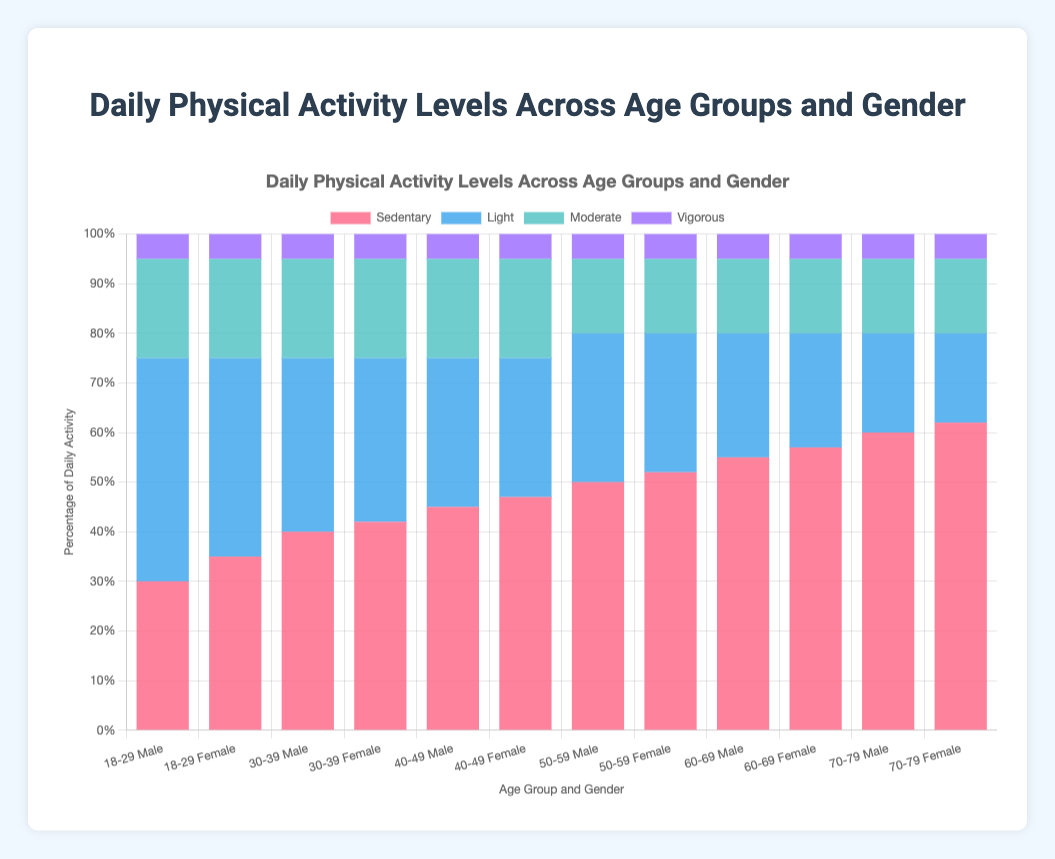Which age group and gender show the highest percentage of sedentary activity? The figure shows a stacked bar chart with different colors for each activity level. The highest percentage of sedentary activity can be visually identified by the bar that has the largest red section. The bar for females aged 70-79 has the largest red section.
Answer: Females 70-79 Which age group and gender have a higher percentage of light activity, males 30-39 or females 30-39? Compare the blue sections of the bars for males 30-39 and females 30-39. The bar for males 30-39 has a blue section representing 35%, whereas females 30-39 have a blue section representing 33%.
Answer: Males 30-39 What is the total percentage of moderate and vigorous activity for males in the age group 18-29? Sum the green and purple sections of the bar for males aged 18-29. The moderate activity is 20% and the vigorous activity is 5%, so the total is 20% + 5% = 25%.
Answer: 25% Which gender has a generally higher percentage of sedentary activity across all age groups: males or females? Look at the red sections for each age group and compare males and females. In each age group, females have a higher percentage of sedentary activity compared to males.
Answer: Females For females aged 50-59, how does the percentage of vigorous activity compare to that of light activity? Identify the colors of the sections for females aged 50-59. The purple section (vigorous) is 5%, and the blue section (light) is 28%. Compare these percentages directly.
Answer: Vigorous (5%) is less than light (28%) Which age group shows the most balanced distribution among the four types of physical activities for males? The most balanced distribution can be observed by looking for the bar where all sections (red, blue, green, and purple) are relatively similar in size. For males, the 18-29 age group shows the most balanced distribution.
Answer: Males 18-29 Are there any age groups where both genders have an equal percentage of moderate activity? Compare the green sections for each age group and gender. The percentage of moderate activity is 20% for both genders in each age group from 18-29 to 40-49.
Answer: Yes, 18-29, 30-39, and 40-49 What is the combined percentage of light and moderate activities for females aged 60-69? Sum the blue and green sections of the bar for females aged 60-69. The light activity is 23% and the moderate activity is 15%, so the total is 23% + 15% = 38%.
Answer: 38% Between males aged 50-59 and 60-69, which group has a higher percentage of sedentary activity? Compare the red sections of the bars for males aged 50-59 and 60-69. Males aged 60-69 have a sedentary activity of 55%, while males aged 50-59 have 50%.
Answer: Males 60-69 